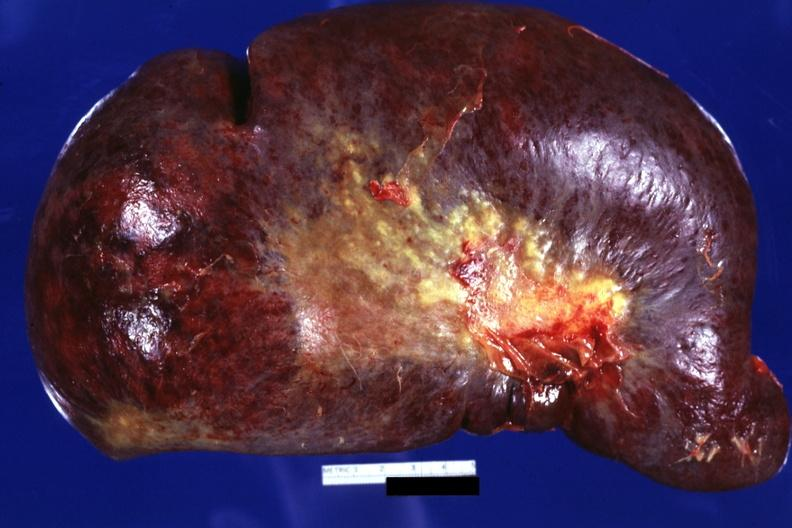s hematologic present?
Answer the question using a single word or phrase. Yes 